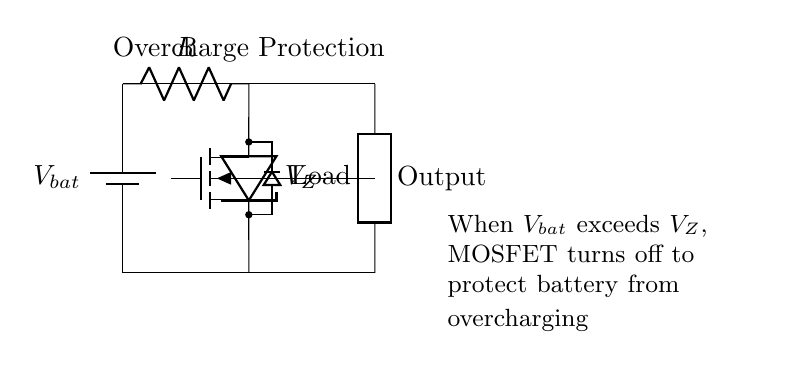What is the main function of the MOSFET in this circuit? The MOSFET acts as a switch that turns off when the battery voltage exceeds the Zener voltage, preventing overcharging.
Answer: switch What happens when the battery voltage exceeds the Zener voltage? When the battery voltage surpasses the Zener voltage, the MOSFET will turn off, cutting off current to prevent further charging, thus protecting the battery.
Answer: MOSFET turns off What component is used to limit the battery voltage? The Zener diode is used in this circuit to limit the battery voltage to a specific level, beyond which the MOSFET switches off.
Answer: Zener diode How many resistors are present in this circuit? There is one resistor indicated in the circuit diagram which is connected in series with the Zener diode and the battery.
Answer: one Which direction does the current flow when the battery is charged? Current flows from the battery through the resistor and the MOSFET to the load when the battery is being charged, shown by the upward connections.
Answer: upward What is the purpose of the resistor connected to the Zener diode? The resistor is used to set up a voltage drop and limit the current flowing through the Zener diode to protect it from damage.
Answer: limit current What does the label "Load" indicate in this circuit? The label "Load" indicates where the output current is delivered, representing the device or electronic component powered by the battery.
Answer: output current delivery 